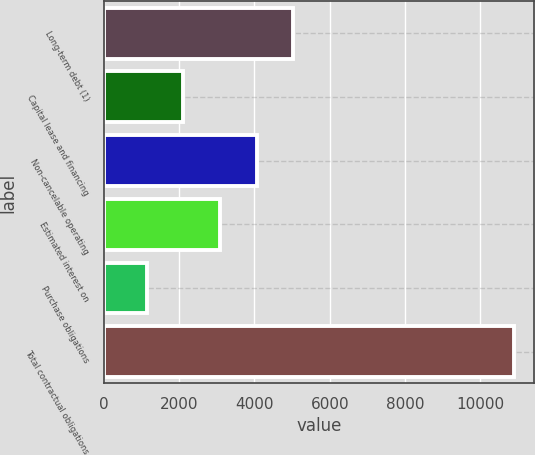Convert chart. <chart><loc_0><loc_0><loc_500><loc_500><bar_chart><fcel>Long-term debt (1)<fcel>Capital lease and financing<fcel>Non-cancelable operating<fcel>Estimated interest on<fcel>Purchase obligations<fcel>Total contractual obligations<nl><fcel>5034<fcel>2112<fcel>4060<fcel>3086<fcel>1138<fcel>10878<nl></chart> 